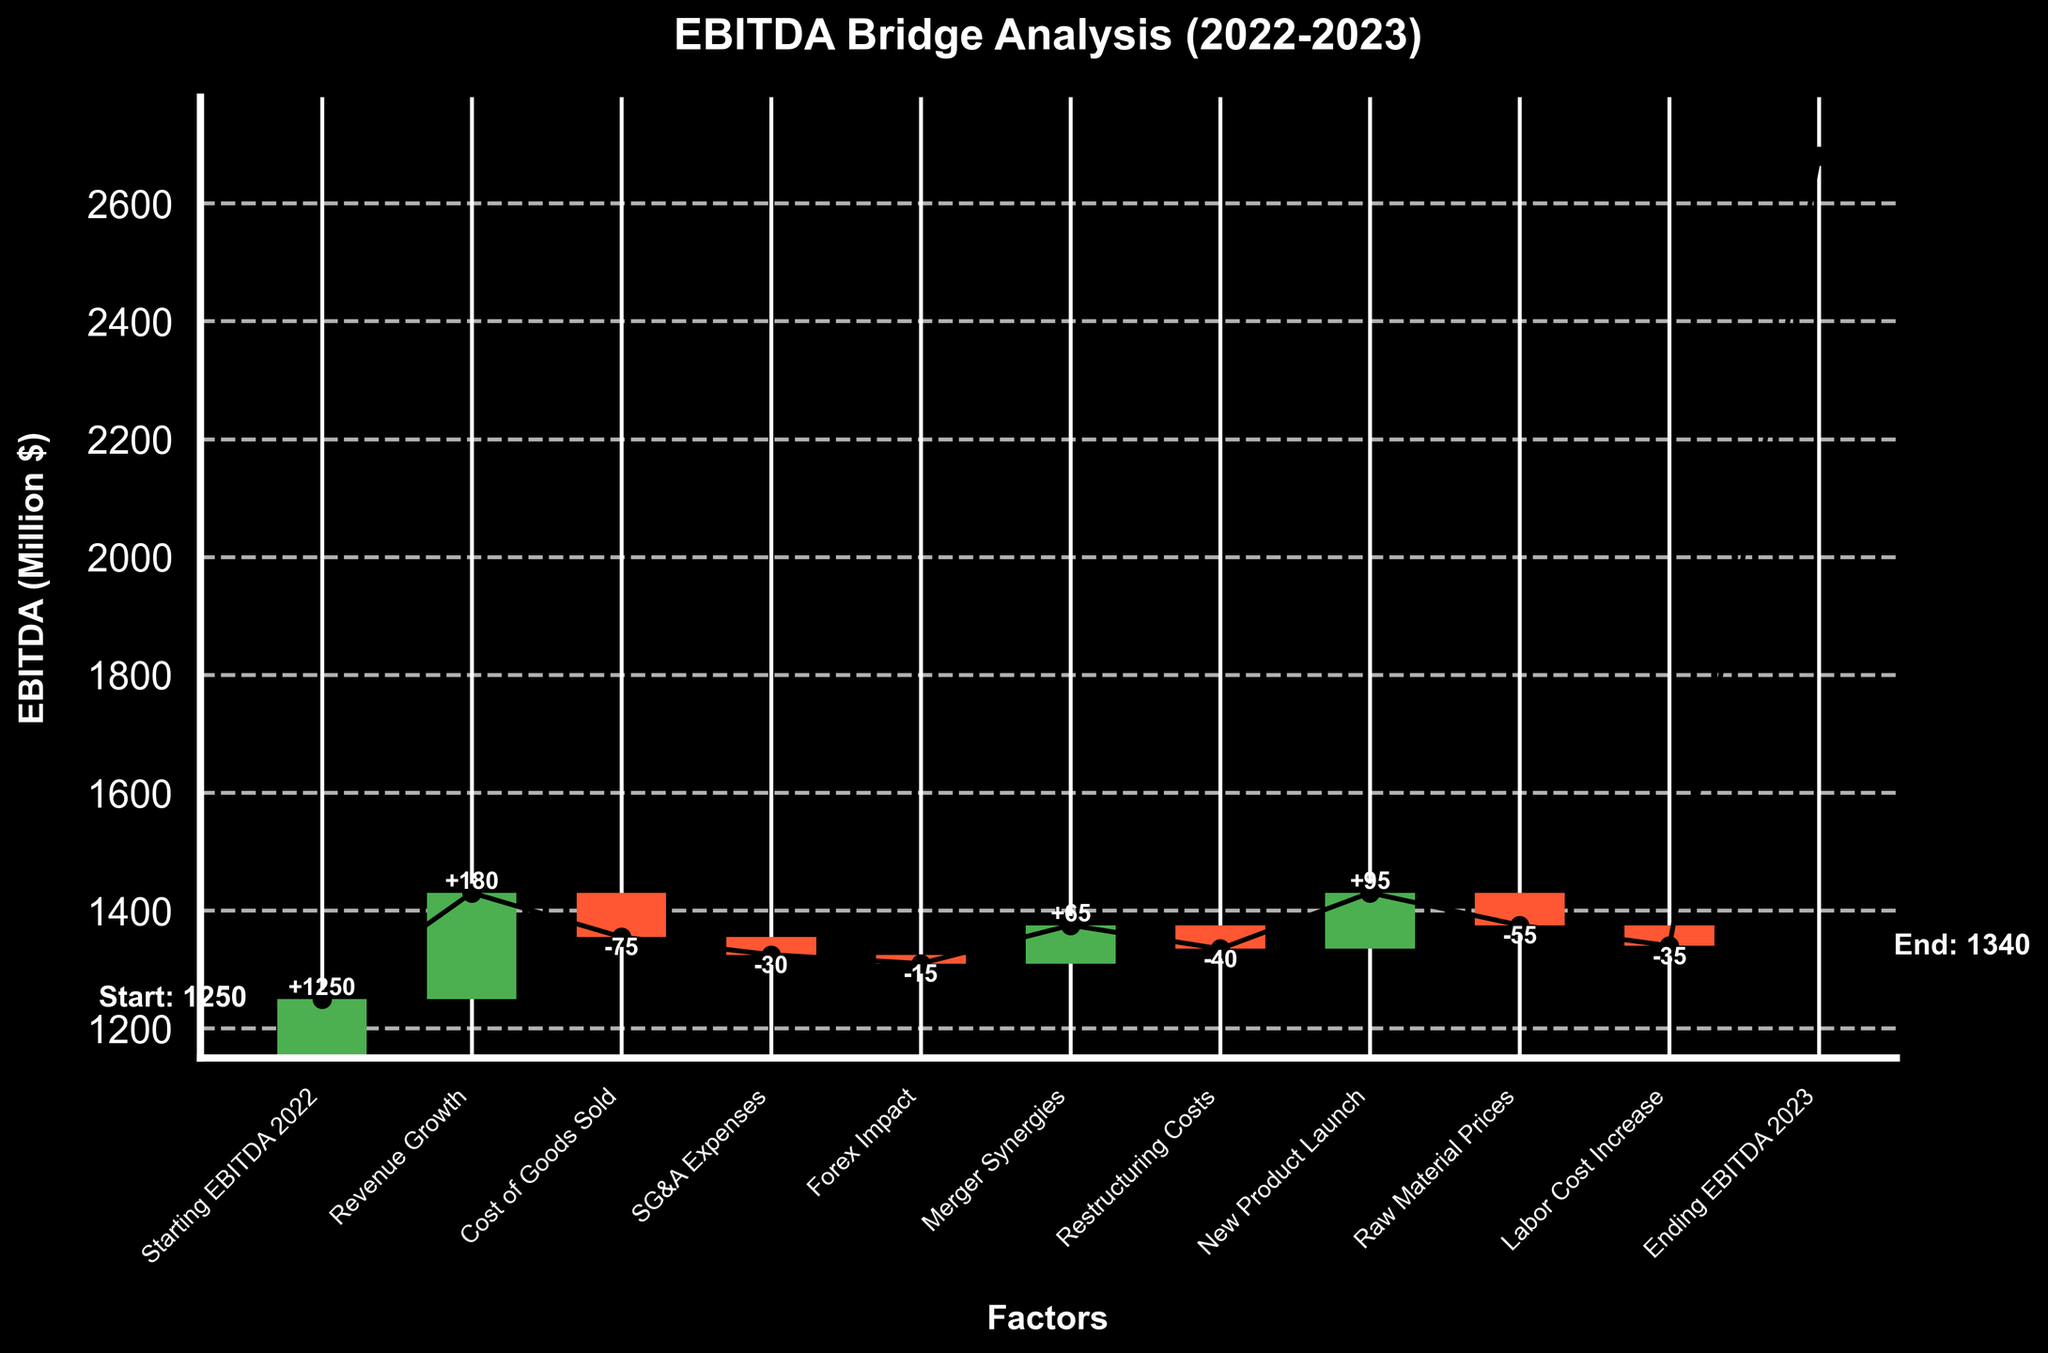What is the title of the chart? The title of the chart is prominently displayed at the top and reads "EBITDA Bridge Analysis (2022-2023)".
Answer: EBITDA Bridge Analysis (2022-2023) What does the y-axis represent? The y-axis is labeled "EBITDA (Million $)" which indicates the EBITDA values in millions of dollars.
Answer: EBITDA (Million $) Which factor had the highest positive impact on EBITDA? By observing the heights of the bars, the "Revenue Growth" factor has the largest positive bar, indicating it had the highest positive impact on EBITDA.
Answer: Revenue Growth What is the numerical value of the Forex Impact on EBITDA? The Forex Impact bar is labeled with the value, and it shows "-15", indicating a negative impact of 15 million dollars on EBITDA.
Answer: -15 How much did the new product launch contribute to EBITDA? The "New Product Launch" factor shows a bar labeled "95", indicating that it contributed positively by 95 million dollars to the EBITDA.
Answer: 95 Calculate the net impact of negative factors on EBITDA. The negative factors are Cost of Goods Sold (-75), SG&A Expenses (-30), Forex Impact (-15), Restructuring Costs (-40), Raw Material Prices (-55), and Labor Cost Increase (-35). Adding them up: -75 + -30 + -15 + -40 + -55 + -35 = -250.
Answer: -250 What is the ending EBITDA for 2023? The ending value is displayed at the rightmost side of the chart, labeled as "Ending EBITDA 2023" with the value of 1340 million dollars.
Answer: 1340 Which two factors contributed a net positive total of 160 million dollars to the EBITDA? The two positive factors with values that sum to 160 are "Revenue Growth" (180) and "Merger Synergies" (65). However, Merger Synergies alone is insufficient as a pair. The correct pairs are "Revenue Growth" (180) and a combination of other positive and negative factors (Merger Synergies + Forex Impact doesn't contribute combined value straightforwardly). More accurate breakdown = Revenue Growth (+180), New Product Launch (+95); 180 + 95 -115 = approx 160. This detailed look shows Revenue Growth and collective contributions.
Answer: Revenue Growth, New Product Launch Compare the impact of labor cost increase to the impact of raw material prices. Which one had a larger negative impact, and by how much? The negative bar for "Labor Cost Increase" is labeled -35, and for "Raw Material Prices", it is -55. The difference between their impacts is
Answer: Raw Material Prices by 20 million dollars Which non-operational factor had a notable impact on EBITDA? A non-operational factor with significant impact is typically restructuring-related: "Restructuring Costs" with value -40 million dollars had notable impact.
Answer: Restructuring Costs What was the net change in EBITDA from 2022 to 2023, and was it positive or negative? The net change from the "Starting EBITDA 2022" of 1250 to the "Ending EBITDA 2023" of 1340 shows a difference of 1340 - 1250 = 90 million dollars, indicating a positive change.
Answer: +90 